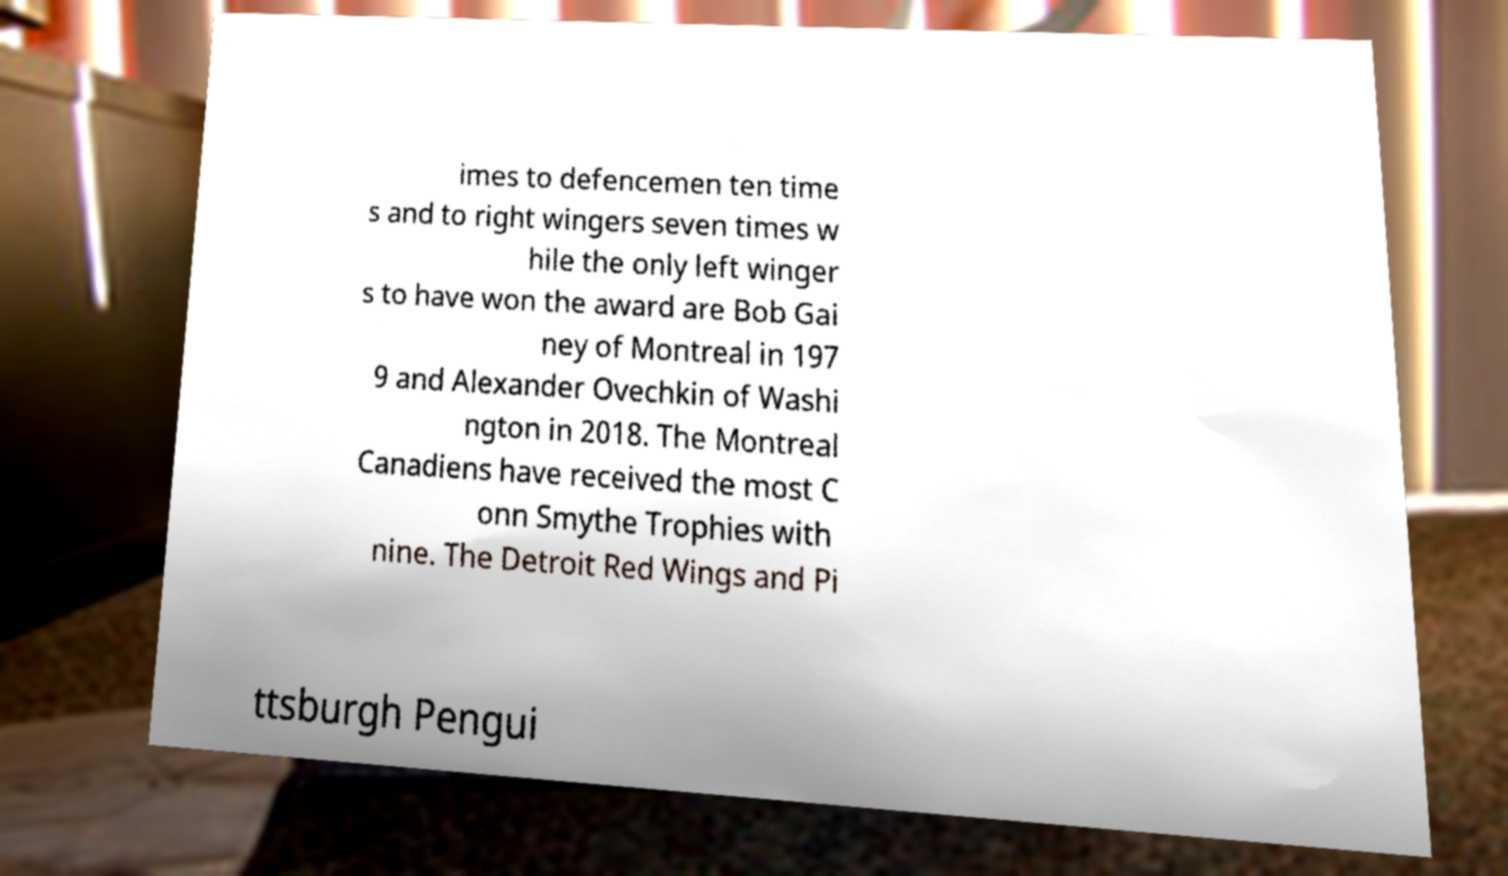Can you read and provide the text displayed in the image?This photo seems to have some interesting text. Can you extract and type it out for me? imes to defencemen ten time s and to right wingers seven times w hile the only left winger s to have won the award are Bob Gai ney of Montreal in 197 9 and Alexander Ovechkin of Washi ngton in 2018. The Montreal Canadiens have received the most C onn Smythe Trophies with nine. The Detroit Red Wings and Pi ttsburgh Pengui 